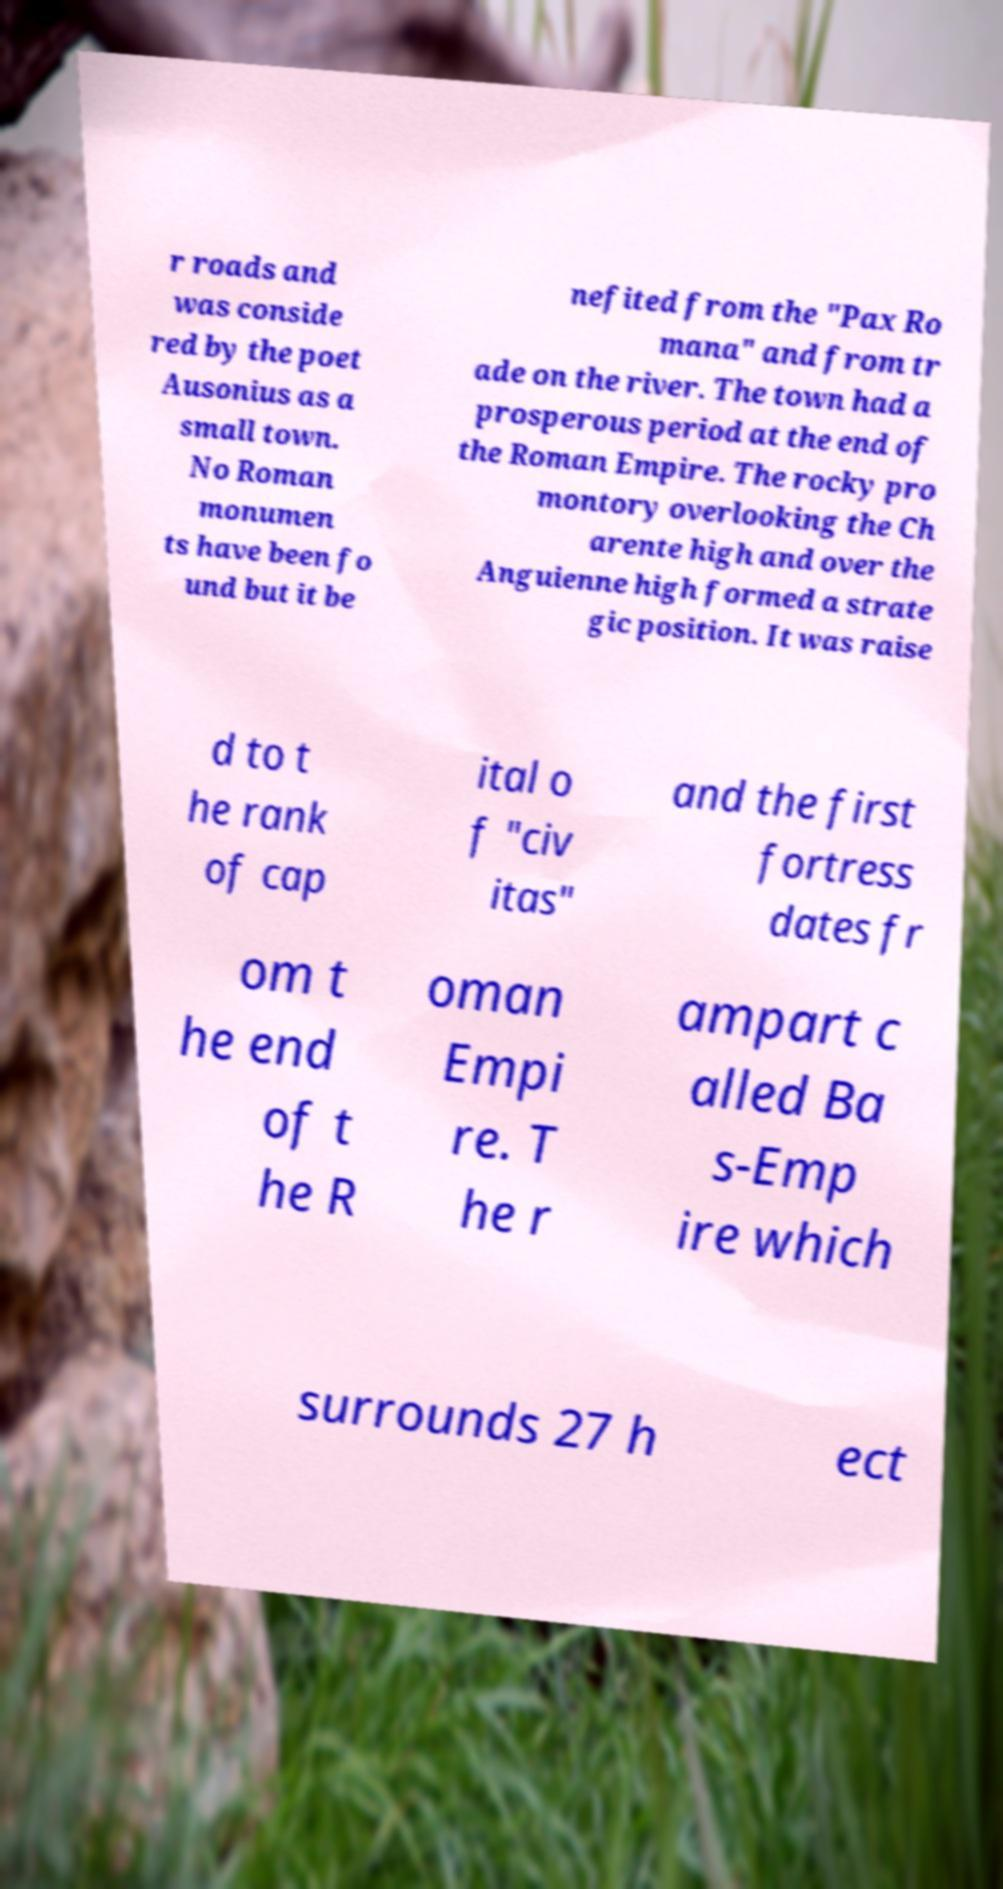Can you accurately transcribe the text from the provided image for me? r roads and was conside red by the poet Ausonius as a small town. No Roman monumen ts have been fo und but it be nefited from the "Pax Ro mana" and from tr ade on the river. The town had a prosperous period at the end of the Roman Empire. The rocky pro montory overlooking the Ch arente high and over the Anguienne high formed a strate gic position. It was raise d to t he rank of cap ital o f "civ itas" and the first fortress dates fr om t he end of t he R oman Empi re. T he r ampart c alled Ba s-Emp ire which surrounds 27 h ect 